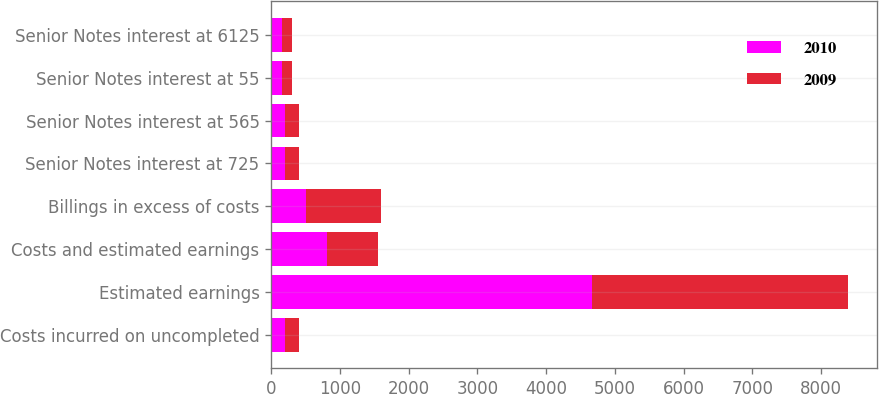<chart> <loc_0><loc_0><loc_500><loc_500><stacked_bar_chart><ecel><fcel>Costs incurred on uncompleted<fcel>Estimated earnings<fcel>Costs and estimated earnings<fcel>Billings in excess of costs<fcel>Senior Notes interest at 725<fcel>Senior Notes interest at 565<fcel>Senior Notes interest at 55<fcel>Senior Notes interest at 6125<nl><fcel>2010<fcel>203<fcel>4665<fcel>815<fcel>511<fcel>201<fcel>200<fcel>151<fcel>151<nl><fcel>2009<fcel>203<fcel>3735<fcel>740<fcel>1090<fcel>205<fcel>200<fcel>151<fcel>151<nl></chart> 